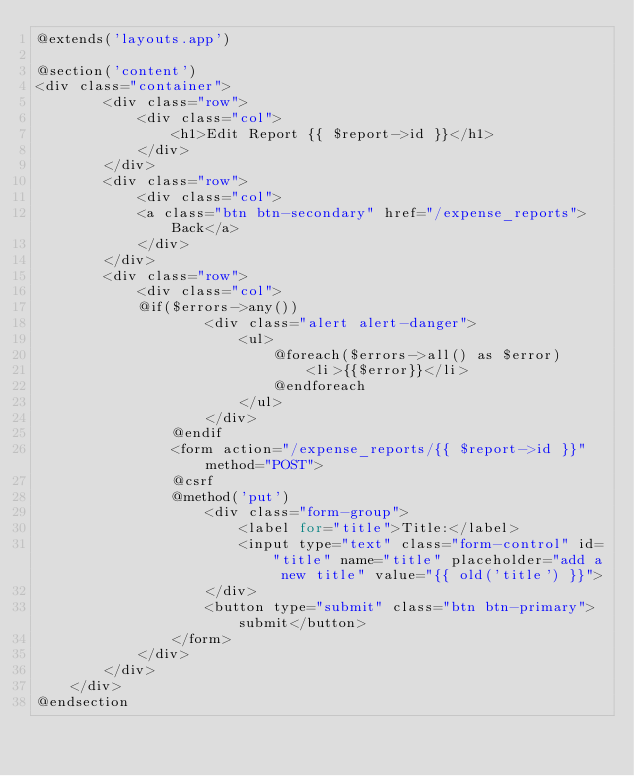<code> <loc_0><loc_0><loc_500><loc_500><_PHP_>@extends('layouts.app')

@section('content')
<div class="container">
        <div class="row">
            <div class="col">
                <h1>Edit Report {{ $report->id }}</h1>
            </div>
        </div>
        <div class="row">
            <div class="col">
            <a class="btn btn-secondary" href="/expense_reports">Back</a>
            </div>
        </div>
        <div class="row">
            <div class="col">
            @if($errors->any())
                    <div class="alert alert-danger">
                        <ul>
                            @foreach($errors->all() as $error)
                                <li>{{$error}}</li>
                            @endforeach
                        </ul>
                    </div>
                @endif
                <form action="/expense_reports/{{ $report->id }}" method="POST">
                @csrf
                @method('put')
                    <div class="form-group">
                        <label for="title">Title:</label>
                        <input type="text" class="form-control" id="title" name="title" placeholder="add a new title" value="{{ old('title') }}">
                    </div>
                    <button type="submit" class="btn btn-primary">submit</button>
                </form>
            </div>
        </div>
    </div>
@endsection
</code> 